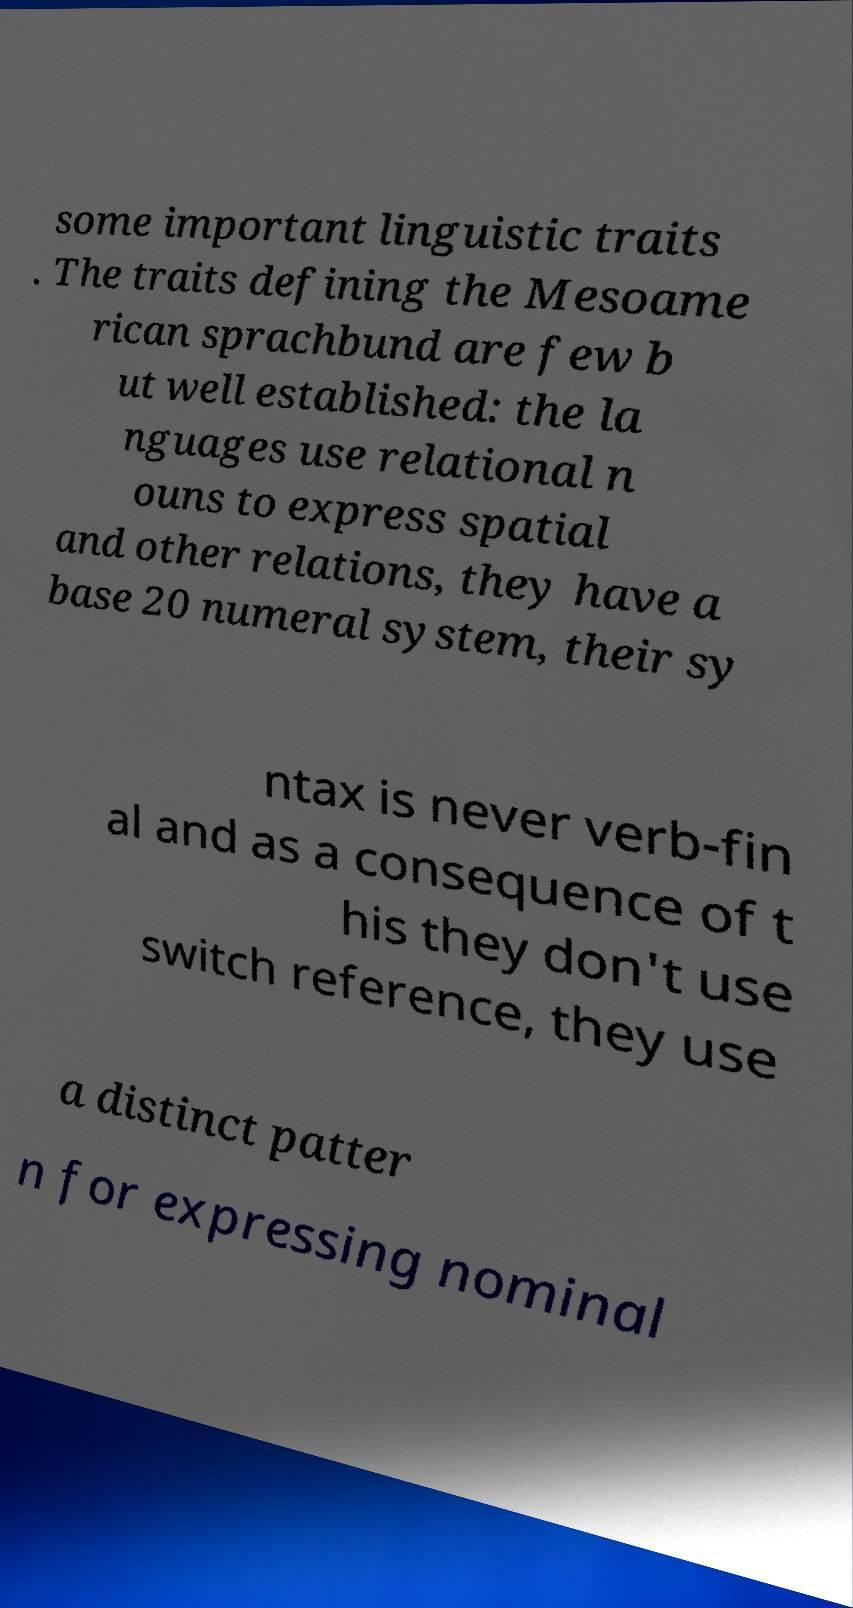There's text embedded in this image that I need extracted. Can you transcribe it verbatim? some important linguistic traits . The traits defining the Mesoame rican sprachbund are few b ut well established: the la nguages use relational n ouns to express spatial and other relations, they have a base 20 numeral system, their sy ntax is never verb-fin al and as a consequence of t his they don't use switch reference, they use a distinct patter n for expressing nominal 